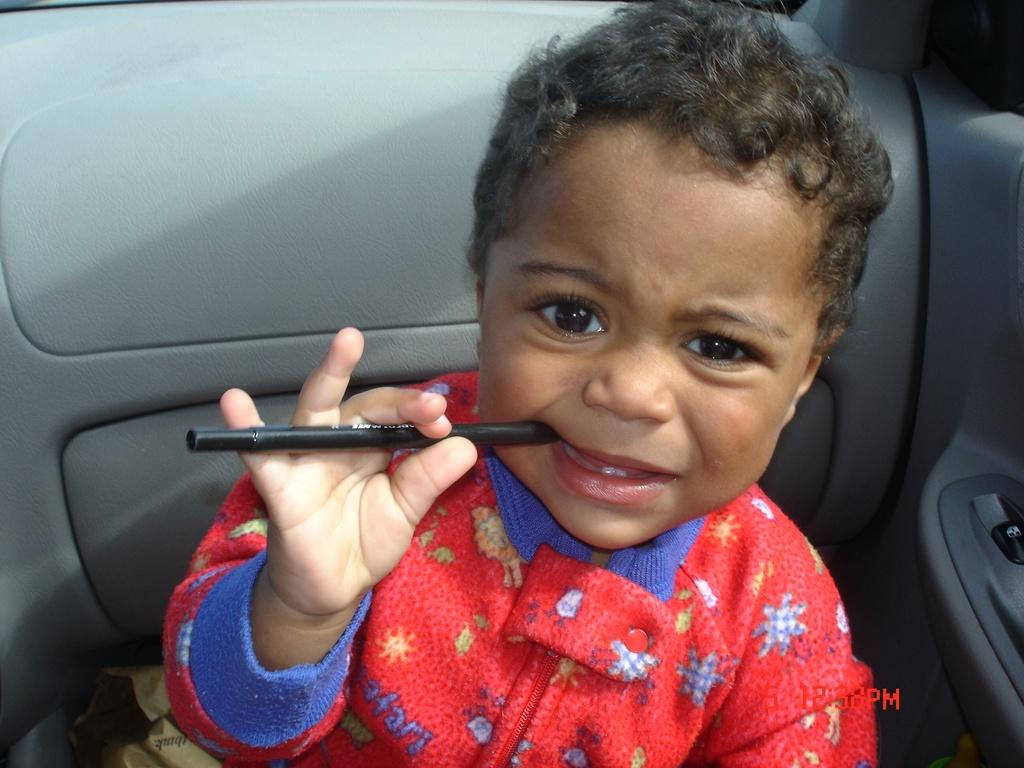What is the main subject of the image? The main subject of the image is a boy. What is the boy holding in the image? The boy is holding a pen. Where is the boy situated in the image? The boy is sitting in a vehicle. What type of bubble can be seen floating around the boy in the image? There is no bubble present in the image; the boy is holding a pen and sitting in a vehicle. What type of car is the boy sitting in the image? The provided facts do not specify the type of vehicle the boy is sitting in, only that he is sitting in a vehicle. 